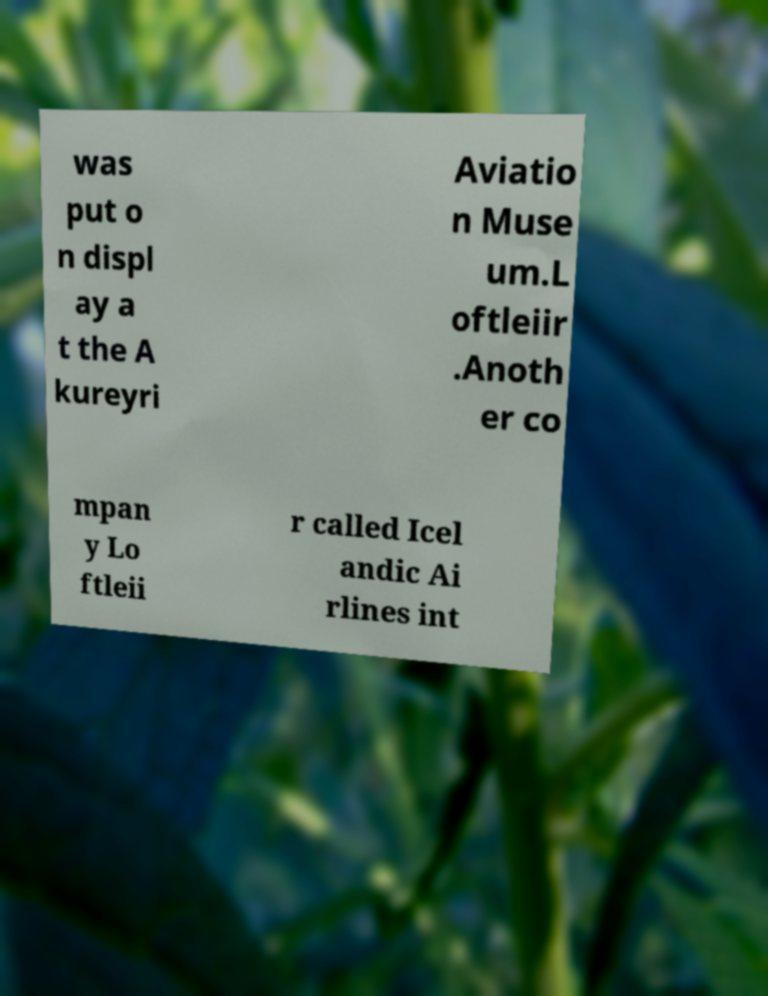What messages or text are displayed in this image? I need them in a readable, typed format. was put o n displ ay a t the A kureyri Aviatio n Muse um.L oftleiir .Anoth er co mpan y Lo ftleii r called Icel andic Ai rlines int 